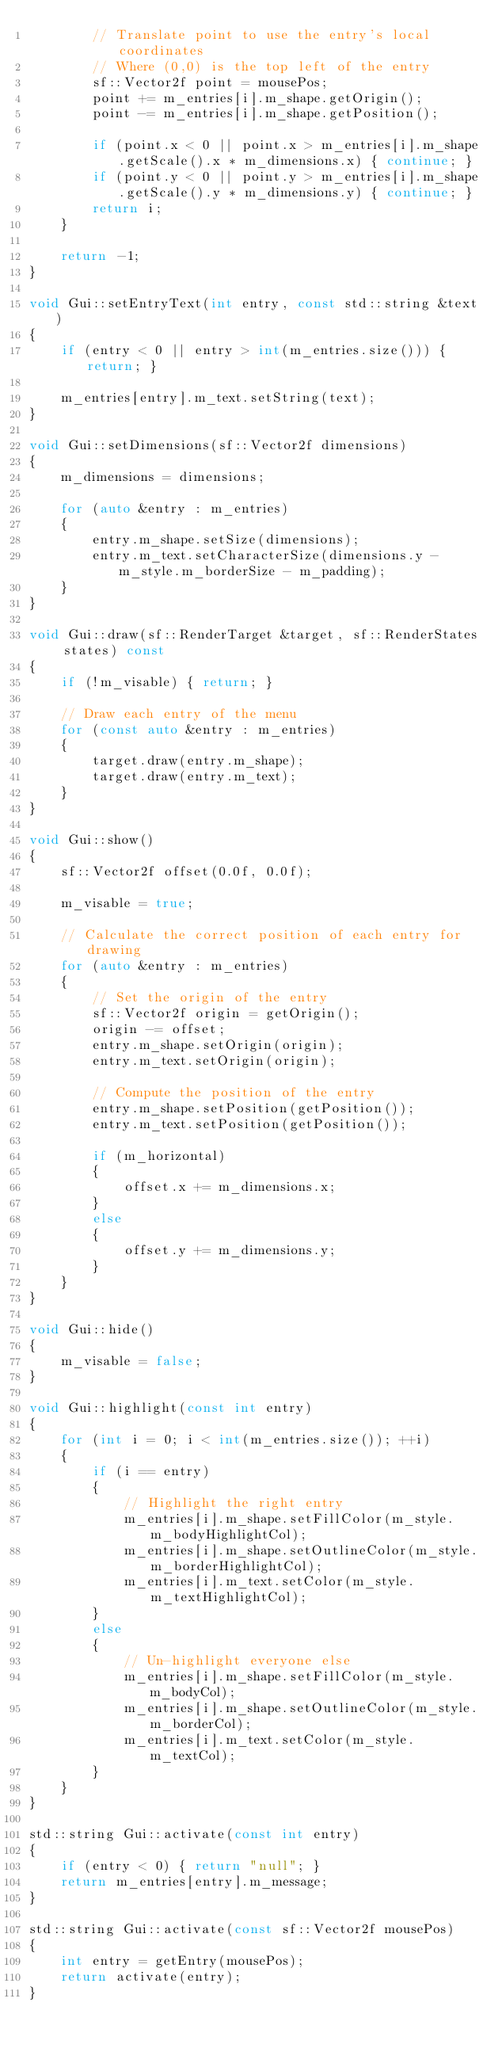Convert code to text. <code><loc_0><loc_0><loc_500><loc_500><_C++_>        // Translate point to use the entry's local coordinates
        // Where (0,0) is the top left of the entry
        sf::Vector2f point = mousePos;
        point += m_entries[i].m_shape.getOrigin();
        point -= m_entries[i].m_shape.getPosition();

        if (point.x < 0 || point.x > m_entries[i].m_shape.getScale().x * m_dimensions.x) { continue; }
        if (point.y < 0 || point.y > m_entries[i].m_shape.getScale().y * m_dimensions.y) { continue; }
        return i;
    }

    return -1;
}

void Gui::setEntryText(int entry, const std::string &text)
{
    if (entry < 0 || entry > int(m_entries.size())) { return; }

    m_entries[entry].m_text.setString(text);
}

void Gui::setDimensions(sf::Vector2f dimensions)
{
    m_dimensions = dimensions;

    for (auto &entry : m_entries)
    {
        entry.m_shape.setSize(dimensions);
        entry.m_text.setCharacterSize(dimensions.y - m_style.m_borderSize - m_padding);
    }
}

void Gui::draw(sf::RenderTarget &target, sf::RenderStates states) const
{
    if (!m_visable) { return; }

    // Draw each entry of the menu
    for (const auto &entry : m_entries)
    {
        target.draw(entry.m_shape);
        target.draw(entry.m_text);
    }
}

void Gui::show()
{
    sf::Vector2f offset(0.0f, 0.0f);

    m_visable = true;

    // Calculate the correct position of each entry for drawing
    for (auto &entry : m_entries)
    {
        // Set the origin of the entry
        sf::Vector2f origin = getOrigin();
        origin -= offset;
        entry.m_shape.setOrigin(origin);
        entry.m_text.setOrigin(origin);

        // Compute the position of the entry
        entry.m_shape.setPosition(getPosition());
        entry.m_text.setPosition(getPosition());

        if (m_horizontal)
        {
            offset.x += m_dimensions.x;
        }
        else
        {
            offset.y += m_dimensions.y;
        }
    }
}

void Gui::hide()
{
    m_visable = false;
}

void Gui::highlight(const int entry)
{
    for (int i = 0; i < int(m_entries.size()); ++i)
    {
        if (i == entry)
        {
            // Highlight the right entry
            m_entries[i].m_shape.setFillColor(m_style.m_bodyHighlightCol);
            m_entries[i].m_shape.setOutlineColor(m_style.m_borderHighlightCol);
            m_entries[i].m_text.setColor(m_style.m_textHighlightCol);
        }
        else
        {
            // Un-highlight everyone else
            m_entries[i].m_shape.setFillColor(m_style.m_bodyCol);
            m_entries[i].m_shape.setOutlineColor(m_style.m_borderCol);
            m_entries[i].m_text.setColor(m_style.m_textCol);
        }
    }
}

std::string Gui::activate(const int entry)
{
    if (entry < 0) { return "null"; }
    return m_entries[entry].m_message;
}

std::string Gui::activate(const sf::Vector2f mousePos)
{
    int entry = getEntry(mousePos);
    return activate(entry);
}</code> 